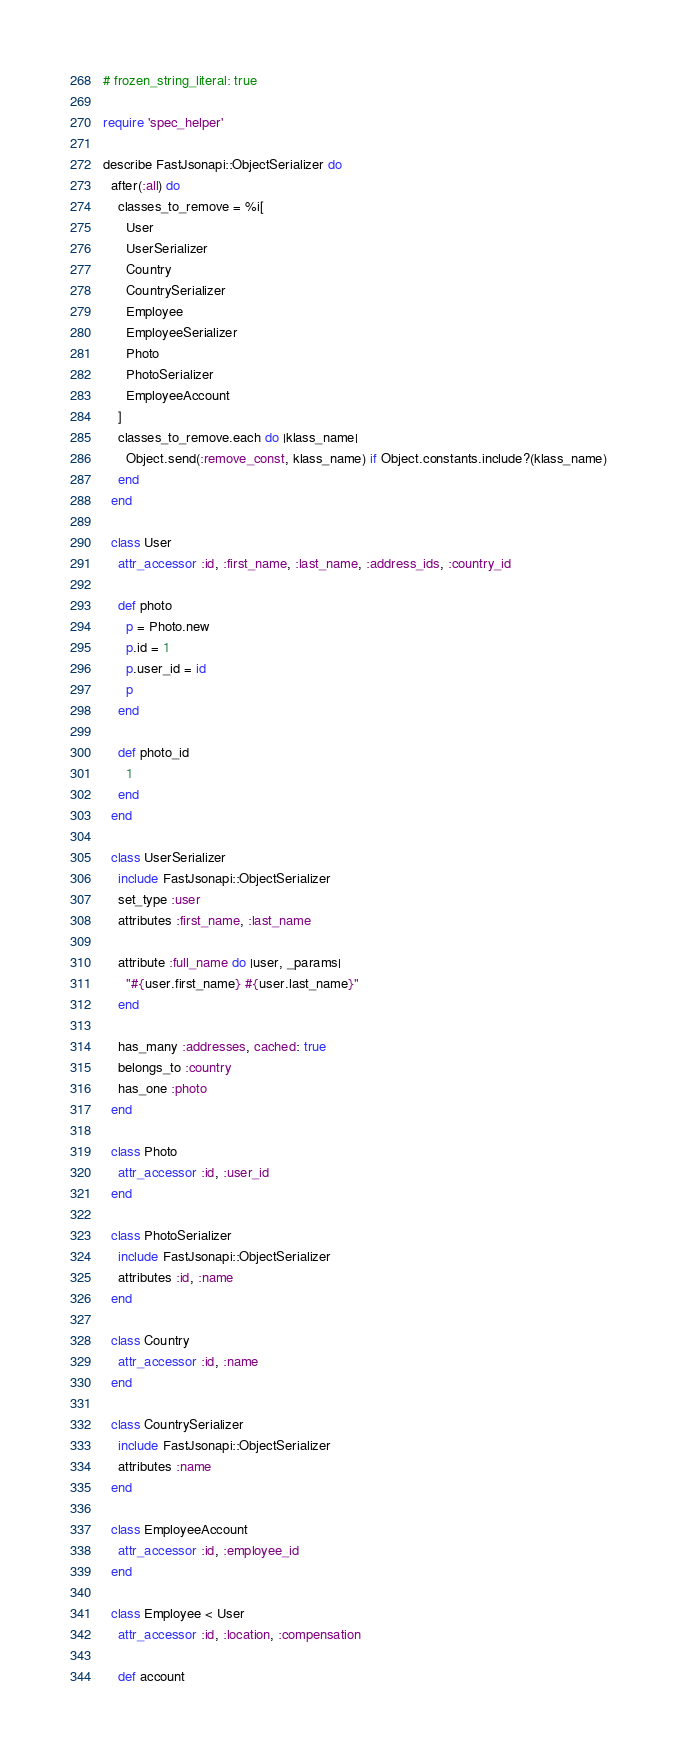Convert code to text. <code><loc_0><loc_0><loc_500><loc_500><_Ruby_># frozen_string_literal: true

require 'spec_helper'

describe FastJsonapi::ObjectSerializer do
  after(:all) do
    classes_to_remove = %i[
      User
      UserSerializer
      Country
      CountrySerializer
      Employee
      EmployeeSerializer
      Photo
      PhotoSerializer
      EmployeeAccount
    ]
    classes_to_remove.each do |klass_name|
      Object.send(:remove_const, klass_name) if Object.constants.include?(klass_name)
    end
  end

  class User
    attr_accessor :id, :first_name, :last_name, :address_ids, :country_id

    def photo
      p = Photo.new
      p.id = 1
      p.user_id = id
      p
    end

    def photo_id
      1
    end
  end

  class UserSerializer
    include FastJsonapi::ObjectSerializer
    set_type :user
    attributes :first_name, :last_name

    attribute :full_name do |user, _params|
      "#{user.first_name} #{user.last_name}"
    end

    has_many :addresses, cached: true
    belongs_to :country
    has_one :photo
  end

  class Photo
    attr_accessor :id, :user_id
  end

  class PhotoSerializer
    include FastJsonapi::ObjectSerializer
    attributes :id, :name
  end

  class Country
    attr_accessor :id, :name
  end

  class CountrySerializer
    include FastJsonapi::ObjectSerializer
    attributes :name
  end

  class EmployeeAccount
    attr_accessor :id, :employee_id
  end

  class Employee < User
    attr_accessor :id, :location, :compensation

    def account</code> 